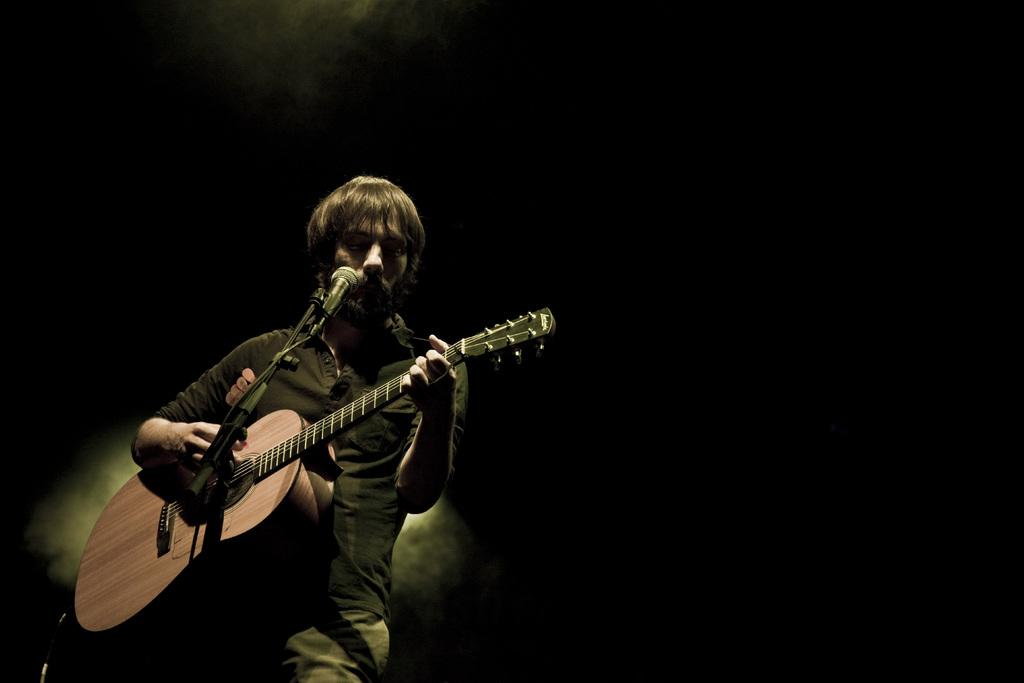What is the main subject of the image? The main subject of the image is a guy. What is the guy wearing in the image? The guy is wearing a black t-shirt. What is the guy holding in the image? The guy is holding a guitar. What is the guy doing with the guitar in the image? The guy is playing the guitar. What is the guy standing in front of in the image? The guy is in front of a microphone. What can be observed about the background of the image? The background of the image is dark. Can you see the guy's father arguing with someone in the image? There is no indication of an argument or the presence of the guy's father in the image. Is there an ant crawling on the guitar in the image? There is no ant visible on the guitar in the image. 